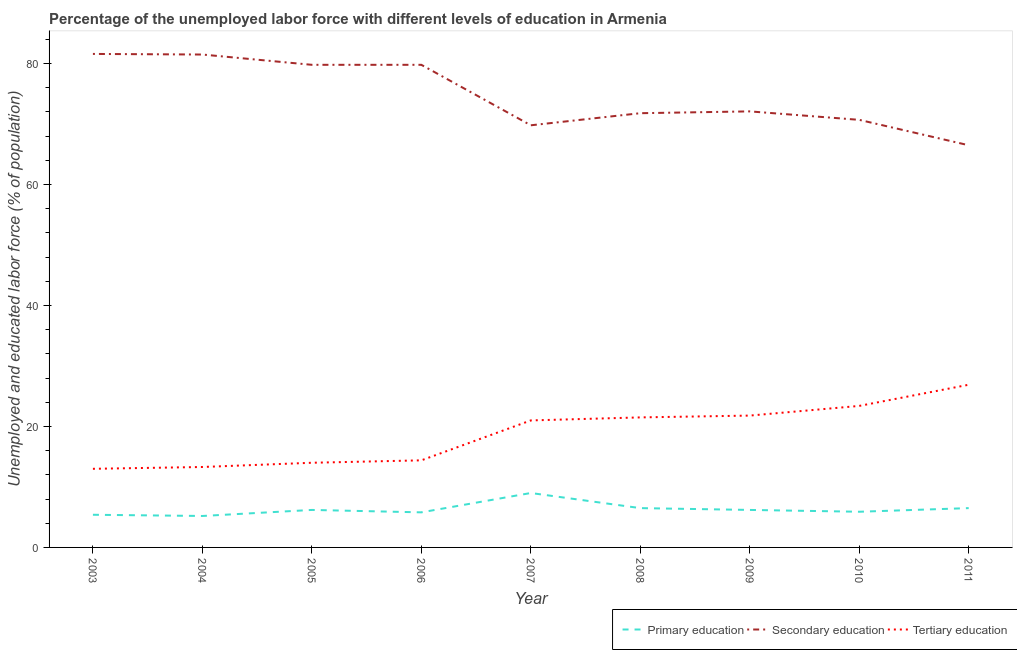How many different coloured lines are there?
Ensure brevity in your answer.  3. What is the percentage of labor force who received secondary education in 2009?
Your response must be concise. 72.1. Across all years, what is the maximum percentage of labor force who received secondary education?
Your answer should be compact. 81.6. In which year was the percentage of labor force who received primary education minimum?
Give a very brief answer. 2004. What is the total percentage of labor force who received tertiary education in the graph?
Offer a terse response. 169.3. What is the difference between the percentage of labor force who received secondary education in 2007 and that in 2008?
Make the answer very short. -2. What is the difference between the percentage of labor force who received tertiary education in 2008 and the percentage of labor force who received primary education in 2009?
Offer a terse response. 15.3. What is the average percentage of labor force who received tertiary education per year?
Your answer should be very brief. 18.81. In the year 2008, what is the difference between the percentage of labor force who received tertiary education and percentage of labor force who received primary education?
Keep it short and to the point. 15. What is the ratio of the percentage of labor force who received primary education in 2008 to that in 2010?
Provide a short and direct response. 1.1. Is the difference between the percentage of labor force who received secondary education in 2010 and 2011 greater than the difference between the percentage of labor force who received tertiary education in 2010 and 2011?
Offer a very short reply. Yes. What is the difference between the highest and the second highest percentage of labor force who received secondary education?
Give a very brief answer. 0.1. What is the difference between the highest and the lowest percentage of labor force who received tertiary education?
Give a very brief answer. 13.9. In how many years, is the percentage of labor force who received secondary education greater than the average percentage of labor force who received secondary education taken over all years?
Make the answer very short. 4. Is it the case that in every year, the sum of the percentage of labor force who received primary education and percentage of labor force who received secondary education is greater than the percentage of labor force who received tertiary education?
Your answer should be very brief. Yes. What is the difference between two consecutive major ticks on the Y-axis?
Give a very brief answer. 20. Does the graph contain grids?
Your answer should be very brief. No. How many legend labels are there?
Offer a very short reply. 3. What is the title of the graph?
Provide a succinct answer. Percentage of the unemployed labor force with different levels of education in Armenia. Does "Spain" appear as one of the legend labels in the graph?
Keep it short and to the point. No. What is the label or title of the X-axis?
Your answer should be compact. Year. What is the label or title of the Y-axis?
Offer a very short reply. Unemployed and educated labor force (% of population). What is the Unemployed and educated labor force (% of population) of Primary education in 2003?
Your answer should be compact. 5.4. What is the Unemployed and educated labor force (% of population) in Secondary education in 2003?
Make the answer very short. 81.6. What is the Unemployed and educated labor force (% of population) in Tertiary education in 2003?
Your response must be concise. 13. What is the Unemployed and educated labor force (% of population) in Primary education in 2004?
Give a very brief answer. 5.2. What is the Unemployed and educated labor force (% of population) of Secondary education in 2004?
Provide a succinct answer. 81.5. What is the Unemployed and educated labor force (% of population) of Tertiary education in 2004?
Provide a succinct answer. 13.3. What is the Unemployed and educated labor force (% of population) of Primary education in 2005?
Your answer should be compact. 6.2. What is the Unemployed and educated labor force (% of population) of Secondary education in 2005?
Offer a terse response. 79.8. What is the Unemployed and educated labor force (% of population) in Tertiary education in 2005?
Keep it short and to the point. 14. What is the Unemployed and educated labor force (% of population) in Primary education in 2006?
Make the answer very short. 5.8. What is the Unemployed and educated labor force (% of population) of Secondary education in 2006?
Your answer should be very brief. 79.8. What is the Unemployed and educated labor force (% of population) of Tertiary education in 2006?
Keep it short and to the point. 14.4. What is the Unemployed and educated labor force (% of population) in Primary education in 2007?
Your answer should be compact. 9. What is the Unemployed and educated labor force (% of population) of Secondary education in 2007?
Offer a very short reply. 69.8. What is the Unemployed and educated labor force (% of population) in Tertiary education in 2007?
Offer a very short reply. 21. What is the Unemployed and educated labor force (% of population) of Secondary education in 2008?
Offer a very short reply. 71.8. What is the Unemployed and educated labor force (% of population) of Primary education in 2009?
Your response must be concise. 6.2. What is the Unemployed and educated labor force (% of population) in Secondary education in 2009?
Give a very brief answer. 72.1. What is the Unemployed and educated labor force (% of population) of Tertiary education in 2009?
Make the answer very short. 21.8. What is the Unemployed and educated labor force (% of population) in Primary education in 2010?
Keep it short and to the point. 5.9. What is the Unemployed and educated labor force (% of population) of Secondary education in 2010?
Give a very brief answer. 70.7. What is the Unemployed and educated labor force (% of population) of Tertiary education in 2010?
Offer a very short reply. 23.4. What is the Unemployed and educated labor force (% of population) of Secondary education in 2011?
Your response must be concise. 66.5. What is the Unemployed and educated labor force (% of population) in Tertiary education in 2011?
Give a very brief answer. 26.9. Across all years, what is the maximum Unemployed and educated labor force (% of population) of Secondary education?
Give a very brief answer. 81.6. Across all years, what is the maximum Unemployed and educated labor force (% of population) of Tertiary education?
Your answer should be very brief. 26.9. Across all years, what is the minimum Unemployed and educated labor force (% of population) of Primary education?
Keep it short and to the point. 5.2. Across all years, what is the minimum Unemployed and educated labor force (% of population) in Secondary education?
Provide a succinct answer. 66.5. Across all years, what is the minimum Unemployed and educated labor force (% of population) in Tertiary education?
Make the answer very short. 13. What is the total Unemployed and educated labor force (% of population) of Primary education in the graph?
Offer a very short reply. 56.7. What is the total Unemployed and educated labor force (% of population) of Secondary education in the graph?
Keep it short and to the point. 673.6. What is the total Unemployed and educated labor force (% of population) of Tertiary education in the graph?
Provide a succinct answer. 169.3. What is the difference between the Unemployed and educated labor force (% of population) in Primary education in 2003 and that in 2004?
Your answer should be compact. 0.2. What is the difference between the Unemployed and educated labor force (% of population) in Secondary education in 2003 and that in 2004?
Keep it short and to the point. 0.1. What is the difference between the Unemployed and educated labor force (% of population) of Secondary education in 2003 and that in 2005?
Offer a terse response. 1.8. What is the difference between the Unemployed and educated labor force (% of population) of Tertiary education in 2003 and that in 2005?
Provide a succinct answer. -1. What is the difference between the Unemployed and educated labor force (% of population) of Secondary education in 2003 and that in 2006?
Your response must be concise. 1.8. What is the difference between the Unemployed and educated labor force (% of population) in Tertiary education in 2003 and that in 2006?
Your response must be concise. -1.4. What is the difference between the Unemployed and educated labor force (% of population) in Tertiary education in 2003 and that in 2007?
Give a very brief answer. -8. What is the difference between the Unemployed and educated labor force (% of population) in Primary education in 2003 and that in 2010?
Give a very brief answer. -0.5. What is the difference between the Unemployed and educated labor force (% of population) in Primary education in 2004 and that in 2005?
Your answer should be very brief. -1. What is the difference between the Unemployed and educated labor force (% of population) of Secondary education in 2004 and that in 2006?
Keep it short and to the point. 1.7. What is the difference between the Unemployed and educated labor force (% of population) of Primary education in 2004 and that in 2007?
Your answer should be compact. -3.8. What is the difference between the Unemployed and educated labor force (% of population) in Secondary education in 2004 and that in 2007?
Your answer should be very brief. 11.7. What is the difference between the Unemployed and educated labor force (% of population) of Tertiary education in 2004 and that in 2007?
Your response must be concise. -7.7. What is the difference between the Unemployed and educated labor force (% of population) of Secondary education in 2004 and that in 2008?
Offer a terse response. 9.7. What is the difference between the Unemployed and educated labor force (% of population) in Tertiary education in 2004 and that in 2008?
Make the answer very short. -8.2. What is the difference between the Unemployed and educated labor force (% of population) in Primary education in 2004 and that in 2009?
Ensure brevity in your answer.  -1. What is the difference between the Unemployed and educated labor force (% of population) in Secondary education in 2004 and that in 2009?
Keep it short and to the point. 9.4. What is the difference between the Unemployed and educated labor force (% of population) in Tertiary education in 2004 and that in 2011?
Your answer should be compact. -13.6. What is the difference between the Unemployed and educated labor force (% of population) of Primary education in 2005 and that in 2006?
Keep it short and to the point. 0.4. What is the difference between the Unemployed and educated labor force (% of population) of Secondary education in 2005 and that in 2007?
Ensure brevity in your answer.  10. What is the difference between the Unemployed and educated labor force (% of population) in Primary education in 2005 and that in 2008?
Your answer should be very brief. -0.3. What is the difference between the Unemployed and educated labor force (% of population) in Tertiary education in 2005 and that in 2008?
Give a very brief answer. -7.5. What is the difference between the Unemployed and educated labor force (% of population) in Primary education in 2005 and that in 2009?
Ensure brevity in your answer.  0. What is the difference between the Unemployed and educated labor force (% of population) in Secondary education in 2005 and that in 2009?
Provide a succinct answer. 7.7. What is the difference between the Unemployed and educated labor force (% of population) of Primary education in 2005 and that in 2010?
Provide a short and direct response. 0.3. What is the difference between the Unemployed and educated labor force (% of population) of Tertiary education in 2005 and that in 2010?
Make the answer very short. -9.4. What is the difference between the Unemployed and educated labor force (% of population) in Primary education in 2005 and that in 2011?
Your answer should be compact. -0.3. What is the difference between the Unemployed and educated labor force (% of population) of Secondary education in 2005 and that in 2011?
Your answer should be very brief. 13.3. What is the difference between the Unemployed and educated labor force (% of population) in Tertiary education in 2005 and that in 2011?
Provide a succinct answer. -12.9. What is the difference between the Unemployed and educated labor force (% of population) in Primary education in 2006 and that in 2007?
Provide a succinct answer. -3.2. What is the difference between the Unemployed and educated labor force (% of population) of Secondary education in 2006 and that in 2007?
Your answer should be compact. 10. What is the difference between the Unemployed and educated labor force (% of population) in Tertiary education in 2006 and that in 2007?
Provide a succinct answer. -6.6. What is the difference between the Unemployed and educated labor force (% of population) of Secondary education in 2006 and that in 2008?
Your answer should be compact. 8. What is the difference between the Unemployed and educated labor force (% of population) of Primary education in 2006 and that in 2009?
Offer a terse response. -0.4. What is the difference between the Unemployed and educated labor force (% of population) in Secondary education in 2006 and that in 2009?
Ensure brevity in your answer.  7.7. What is the difference between the Unemployed and educated labor force (% of population) in Primary education in 2006 and that in 2010?
Offer a very short reply. -0.1. What is the difference between the Unemployed and educated labor force (% of population) in Secondary education in 2006 and that in 2010?
Ensure brevity in your answer.  9.1. What is the difference between the Unemployed and educated labor force (% of population) of Tertiary education in 2006 and that in 2010?
Make the answer very short. -9. What is the difference between the Unemployed and educated labor force (% of population) in Primary education in 2006 and that in 2011?
Provide a succinct answer. -0.7. What is the difference between the Unemployed and educated labor force (% of population) of Secondary education in 2006 and that in 2011?
Provide a short and direct response. 13.3. What is the difference between the Unemployed and educated labor force (% of population) of Tertiary education in 2006 and that in 2011?
Give a very brief answer. -12.5. What is the difference between the Unemployed and educated labor force (% of population) in Primary education in 2007 and that in 2008?
Your answer should be very brief. 2.5. What is the difference between the Unemployed and educated labor force (% of population) of Secondary education in 2007 and that in 2008?
Your answer should be very brief. -2. What is the difference between the Unemployed and educated labor force (% of population) in Tertiary education in 2007 and that in 2009?
Offer a very short reply. -0.8. What is the difference between the Unemployed and educated labor force (% of population) in Secondary education in 2007 and that in 2010?
Give a very brief answer. -0.9. What is the difference between the Unemployed and educated labor force (% of population) of Primary education in 2007 and that in 2011?
Offer a terse response. 2.5. What is the difference between the Unemployed and educated labor force (% of population) of Tertiary education in 2007 and that in 2011?
Your answer should be very brief. -5.9. What is the difference between the Unemployed and educated labor force (% of population) in Primary education in 2008 and that in 2009?
Provide a short and direct response. 0.3. What is the difference between the Unemployed and educated labor force (% of population) in Primary education in 2008 and that in 2010?
Provide a succinct answer. 0.6. What is the difference between the Unemployed and educated labor force (% of population) of Tertiary education in 2008 and that in 2011?
Offer a very short reply. -5.4. What is the difference between the Unemployed and educated labor force (% of population) in Secondary education in 2009 and that in 2010?
Your response must be concise. 1.4. What is the difference between the Unemployed and educated labor force (% of population) in Tertiary education in 2009 and that in 2010?
Provide a short and direct response. -1.6. What is the difference between the Unemployed and educated labor force (% of population) in Secondary education in 2009 and that in 2011?
Offer a terse response. 5.6. What is the difference between the Unemployed and educated labor force (% of population) in Tertiary education in 2009 and that in 2011?
Give a very brief answer. -5.1. What is the difference between the Unemployed and educated labor force (% of population) in Primary education in 2003 and the Unemployed and educated labor force (% of population) in Secondary education in 2004?
Give a very brief answer. -76.1. What is the difference between the Unemployed and educated labor force (% of population) of Primary education in 2003 and the Unemployed and educated labor force (% of population) of Tertiary education in 2004?
Keep it short and to the point. -7.9. What is the difference between the Unemployed and educated labor force (% of population) in Secondary education in 2003 and the Unemployed and educated labor force (% of population) in Tertiary education in 2004?
Provide a short and direct response. 68.3. What is the difference between the Unemployed and educated labor force (% of population) in Primary education in 2003 and the Unemployed and educated labor force (% of population) in Secondary education in 2005?
Provide a succinct answer. -74.4. What is the difference between the Unemployed and educated labor force (% of population) in Primary education in 2003 and the Unemployed and educated labor force (% of population) in Tertiary education in 2005?
Offer a very short reply. -8.6. What is the difference between the Unemployed and educated labor force (% of population) of Secondary education in 2003 and the Unemployed and educated labor force (% of population) of Tertiary education in 2005?
Give a very brief answer. 67.6. What is the difference between the Unemployed and educated labor force (% of population) in Primary education in 2003 and the Unemployed and educated labor force (% of population) in Secondary education in 2006?
Your answer should be very brief. -74.4. What is the difference between the Unemployed and educated labor force (% of population) in Primary education in 2003 and the Unemployed and educated labor force (% of population) in Tertiary education in 2006?
Your answer should be compact. -9. What is the difference between the Unemployed and educated labor force (% of population) of Secondary education in 2003 and the Unemployed and educated labor force (% of population) of Tertiary education in 2006?
Offer a terse response. 67.2. What is the difference between the Unemployed and educated labor force (% of population) of Primary education in 2003 and the Unemployed and educated labor force (% of population) of Secondary education in 2007?
Provide a succinct answer. -64.4. What is the difference between the Unemployed and educated labor force (% of population) in Primary education in 2003 and the Unemployed and educated labor force (% of population) in Tertiary education in 2007?
Keep it short and to the point. -15.6. What is the difference between the Unemployed and educated labor force (% of population) in Secondary education in 2003 and the Unemployed and educated labor force (% of population) in Tertiary education in 2007?
Your response must be concise. 60.6. What is the difference between the Unemployed and educated labor force (% of population) in Primary education in 2003 and the Unemployed and educated labor force (% of population) in Secondary education in 2008?
Make the answer very short. -66.4. What is the difference between the Unemployed and educated labor force (% of population) of Primary education in 2003 and the Unemployed and educated labor force (% of population) of Tertiary education in 2008?
Provide a succinct answer. -16.1. What is the difference between the Unemployed and educated labor force (% of population) of Secondary education in 2003 and the Unemployed and educated labor force (% of population) of Tertiary education in 2008?
Provide a short and direct response. 60.1. What is the difference between the Unemployed and educated labor force (% of population) of Primary education in 2003 and the Unemployed and educated labor force (% of population) of Secondary education in 2009?
Give a very brief answer. -66.7. What is the difference between the Unemployed and educated labor force (% of population) of Primary education in 2003 and the Unemployed and educated labor force (% of population) of Tertiary education in 2009?
Offer a very short reply. -16.4. What is the difference between the Unemployed and educated labor force (% of population) in Secondary education in 2003 and the Unemployed and educated labor force (% of population) in Tertiary education in 2009?
Your response must be concise. 59.8. What is the difference between the Unemployed and educated labor force (% of population) of Primary education in 2003 and the Unemployed and educated labor force (% of population) of Secondary education in 2010?
Your answer should be very brief. -65.3. What is the difference between the Unemployed and educated labor force (% of population) of Primary education in 2003 and the Unemployed and educated labor force (% of population) of Tertiary education in 2010?
Make the answer very short. -18. What is the difference between the Unemployed and educated labor force (% of population) in Secondary education in 2003 and the Unemployed and educated labor force (% of population) in Tertiary education in 2010?
Provide a short and direct response. 58.2. What is the difference between the Unemployed and educated labor force (% of population) of Primary education in 2003 and the Unemployed and educated labor force (% of population) of Secondary education in 2011?
Keep it short and to the point. -61.1. What is the difference between the Unemployed and educated labor force (% of population) of Primary education in 2003 and the Unemployed and educated labor force (% of population) of Tertiary education in 2011?
Offer a terse response. -21.5. What is the difference between the Unemployed and educated labor force (% of population) in Secondary education in 2003 and the Unemployed and educated labor force (% of population) in Tertiary education in 2011?
Offer a very short reply. 54.7. What is the difference between the Unemployed and educated labor force (% of population) of Primary education in 2004 and the Unemployed and educated labor force (% of population) of Secondary education in 2005?
Your response must be concise. -74.6. What is the difference between the Unemployed and educated labor force (% of population) of Secondary education in 2004 and the Unemployed and educated labor force (% of population) of Tertiary education in 2005?
Keep it short and to the point. 67.5. What is the difference between the Unemployed and educated labor force (% of population) of Primary education in 2004 and the Unemployed and educated labor force (% of population) of Secondary education in 2006?
Give a very brief answer. -74.6. What is the difference between the Unemployed and educated labor force (% of population) in Primary education in 2004 and the Unemployed and educated labor force (% of population) in Tertiary education in 2006?
Your response must be concise. -9.2. What is the difference between the Unemployed and educated labor force (% of population) in Secondary education in 2004 and the Unemployed and educated labor force (% of population) in Tertiary education in 2006?
Your answer should be compact. 67.1. What is the difference between the Unemployed and educated labor force (% of population) in Primary education in 2004 and the Unemployed and educated labor force (% of population) in Secondary education in 2007?
Your answer should be very brief. -64.6. What is the difference between the Unemployed and educated labor force (% of population) in Primary education in 2004 and the Unemployed and educated labor force (% of population) in Tertiary education in 2007?
Provide a succinct answer. -15.8. What is the difference between the Unemployed and educated labor force (% of population) in Secondary education in 2004 and the Unemployed and educated labor force (% of population) in Tertiary education in 2007?
Provide a short and direct response. 60.5. What is the difference between the Unemployed and educated labor force (% of population) in Primary education in 2004 and the Unemployed and educated labor force (% of population) in Secondary education in 2008?
Your response must be concise. -66.6. What is the difference between the Unemployed and educated labor force (% of population) in Primary education in 2004 and the Unemployed and educated labor force (% of population) in Tertiary education in 2008?
Offer a very short reply. -16.3. What is the difference between the Unemployed and educated labor force (% of population) of Primary education in 2004 and the Unemployed and educated labor force (% of population) of Secondary education in 2009?
Keep it short and to the point. -66.9. What is the difference between the Unemployed and educated labor force (% of population) in Primary education in 2004 and the Unemployed and educated labor force (% of population) in Tertiary education in 2009?
Offer a terse response. -16.6. What is the difference between the Unemployed and educated labor force (% of population) of Secondary education in 2004 and the Unemployed and educated labor force (% of population) of Tertiary education in 2009?
Provide a succinct answer. 59.7. What is the difference between the Unemployed and educated labor force (% of population) of Primary education in 2004 and the Unemployed and educated labor force (% of population) of Secondary education in 2010?
Your answer should be very brief. -65.5. What is the difference between the Unemployed and educated labor force (% of population) in Primary education in 2004 and the Unemployed and educated labor force (% of population) in Tertiary education in 2010?
Keep it short and to the point. -18.2. What is the difference between the Unemployed and educated labor force (% of population) of Secondary education in 2004 and the Unemployed and educated labor force (% of population) of Tertiary education in 2010?
Your answer should be very brief. 58.1. What is the difference between the Unemployed and educated labor force (% of population) of Primary education in 2004 and the Unemployed and educated labor force (% of population) of Secondary education in 2011?
Provide a short and direct response. -61.3. What is the difference between the Unemployed and educated labor force (% of population) in Primary education in 2004 and the Unemployed and educated labor force (% of population) in Tertiary education in 2011?
Ensure brevity in your answer.  -21.7. What is the difference between the Unemployed and educated labor force (% of population) in Secondary education in 2004 and the Unemployed and educated labor force (% of population) in Tertiary education in 2011?
Offer a very short reply. 54.6. What is the difference between the Unemployed and educated labor force (% of population) in Primary education in 2005 and the Unemployed and educated labor force (% of population) in Secondary education in 2006?
Offer a terse response. -73.6. What is the difference between the Unemployed and educated labor force (% of population) of Primary education in 2005 and the Unemployed and educated labor force (% of population) of Tertiary education in 2006?
Ensure brevity in your answer.  -8.2. What is the difference between the Unemployed and educated labor force (% of population) in Secondary education in 2005 and the Unemployed and educated labor force (% of population) in Tertiary education in 2006?
Offer a very short reply. 65.4. What is the difference between the Unemployed and educated labor force (% of population) in Primary education in 2005 and the Unemployed and educated labor force (% of population) in Secondary education in 2007?
Give a very brief answer. -63.6. What is the difference between the Unemployed and educated labor force (% of population) of Primary education in 2005 and the Unemployed and educated labor force (% of population) of Tertiary education in 2007?
Give a very brief answer. -14.8. What is the difference between the Unemployed and educated labor force (% of population) of Secondary education in 2005 and the Unemployed and educated labor force (% of population) of Tertiary education in 2007?
Ensure brevity in your answer.  58.8. What is the difference between the Unemployed and educated labor force (% of population) in Primary education in 2005 and the Unemployed and educated labor force (% of population) in Secondary education in 2008?
Ensure brevity in your answer.  -65.6. What is the difference between the Unemployed and educated labor force (% of population) in Primary education in 2005 and the Unemployed and educated labor force (% of population) in Tertiary education in 2008?
Give a very brief answer. -15.3. What is the difference between the Unemployed and educated labor force (% of population) of Secondary education in 2005 and the Unemployed and educated labor force (% of population) of Tertiary education in 2008?
Offer a terse response. 58.3. What is the difference between the Unemployed and educated labor force (% of population) in Primary education in 2005 and the Unemployed and educated labor force (% of population) in Secondary education in 2009?
Offer a terse response. -65.9. What is the difference between the Unemployed and educated labor force (% of population) of Primary education in 2005 and the Unemployed and educated labor force (% of population) of Tertiary education in 2009?
Keep it short and to the point. -15.6. What is the difference between the Unemployed and educated labor force (% of population) of Primary education in 2005 and the Unemployed and educated labor force (% of population) of Secondary education in 2010?
Keep it short and to the point. -64.5. What is the difference between the Unemployed and educated labor force (% of population) in Primary education in 2005 and the Unemployed and educated labor force (% of population) in Tertiary education in 2010?
Provide a succinct answer. -17.2. What is the difference between the Unemployed and educated labor force (% of population) of Secondary education in 2005 and the Unemployed and educated labor force (% of population) of Tertiary education in 2010?
Ensure brevity in your answer.  56.4. What is the difference between the Unemployed and educated labor force (% of population) of Primary education in 2005 and the Unemployed and educated labor force (% of population) of Secondary education in 2011?
Keep it short and to the point. -60.3. What is the difference between the Unemployed and educated labor force (% of population) in Primary education in 2005 and the Unemployed and educated labor force (% of population) in Tertiary education in 2011?
Offer a terse response. -20.7. What is the difference between the Unemployed and educated labor force (% of population) of Secondary education in 2005 and the Unemployed and educated labor force (% of population) of Tertiary education in 2011?
Offer a terse response. 52.9. What is the difference between the Unemployed and educated labor force (% of population) in Primary education in 2006 and the Unemployed and educated labor force (% of population) in Secondary education in 2007?
Your answer should be very brief. -64. What is the difference between the Unemployed and educated labor force (% of population) of Primary education in 2006 and the Unemployed and educated labor force (% of population) of Tertiary education in 2007?
Provide a short and direct response. -15.2. What is the difference between the Unemployed and educated labor force (% of population) of Secondary education in 2006 and the Unemployed and educated labor force (% of population) of Tertiary education in 2007?
Give a very brief answer. 58.8. What is the difference between the Unemployed and educated labor force (% of population) in Primary education in 2006 and the Unemployed and educated labor force (% of population) in Secondary education in 2008?
Offer a very short reply. -66. What is the difference between the Unemployed and educated labor force (% of population) of Primary education in 2006 and the Unemployed and educated labor force (% of population) of Tertiary education in 2008?
Your answer should be very brief. -15.7. What is the difference between the Unemployed and educated labor force (% of population) in Secondary education in 2006 and the Unemployed and educated labor force (% of population) in Tertiary education in 2008?
Your answer should be very brief. 58.3. What is the difference between the Unemployed and educated labor force (% of population) in Primary education in 2006 and the Unemployed and educated labor force (% of population) in Secondary education in 2009?
Ensure brevity in your answer.  -66.3. What is the difference between the Unemployed and educated labor force (% of population) of Primary education in 2006 and the Unemployed and educated labor force (% of population) of Tertiary education in 2009?
Give a very brief answer. -16. What is the difference between the Unemployed and educated labor force (% of population) in Primary education in 2006 and the Unemployed and educated labor force (% of population) in Secondary education in 2010?
Offer a terse response. -64.9. What is the difference between the Unemployed and educated labor force (% of population) in Primary education in 2006 and the Unemployed and educated labor force (% of population) in Tertiary education in 2010?
Provide a succinct answer. -17.6. What is the difference between the Unemployed and educated labor force (% of population) in Secondary education in 2006 and the Unemployed and educated labor force (% of population) in Tertiary education in 2010?
Your answer should be compact. 56.4. What is the difference between the Unemployed and educated labor force (% of population) of Primary education in 2006 and the Unemployed and educated labor force (% of population) of Secondary education in 2011?
Give a very brief answer. -60.7. What is the difference between the Unemployed and educated labor force (% of population) of Primary education in 2006 and the Unemployed and educated labor force (% of population) of Tertiary education in 2011?
Offer a terse response. -21.1. What is the difference between the Unemployed and educated labor force (% of population) in Secondary education in 2006 and the Unemployed and educated labor force (% of population) in Tertiary education in 2011?
Your response must be concise. 52.9. What is the difference between the Unemployed and educated labor force (% of population) of Primary education in 2007 and the Unemployed and educated labor force (% of population) of Secondary education in 2008?
Your answer should be very brief. -62.8. What is the difference between the Unemployed and educated labor force (% of population) in Primary education in 2007 and the Unemployed and educated labor force (% of population) in Tertiary education in 2008?
Provide a short and direct response. -12.5. What is the difference between the Unemployed and educated labor force (% of population) in Secondary education in 2007 and the Unemployed and educated labor force (% of population) in Tertiary education in 2008?
Ensure brevity in your answer.  48.3. What is the difference between the Unemployed and educated labor force (% of population) of Primary education in 2007 and the Unemployed and educated labor force (% of population) of Secondary education in 2009?
Provide a succinct answer. -63.1. What is the difference between the Unemployed and educated labor force (% of population) of Primary education in 2007 and the Unemployed and educated labor force (% of population) of Tertiary education in 2009?
Ensure brevity in your answer.  -12.8. What is the difference between the Unemployed and educated labor force (% of population) of Primary education in 2007 and the Unemployed and educated labor force (% of population) of Secondary education in 2010?
Keep it short and to the point. -61.7. What is the difference between the Unemployed and educated labor force (% of population) of Primary education in 2007 and the Unemployed and educated labor force (% of population) of Tertiary education in 2010?
Make the answer very short. -14.4. What is the difference between the Unemployed and educated labor force (% of population) in Secondary education in 2007 and the Unemployed and educated labor force (% of population) in Tertiary education in 2010?
Your response must be concise. 46.4. What is the difference between the Unemployed and educated labor force (% of population) in Primary education in 2007 and the Unemployed and educated labor force (% of population) in Secondary education in 2011?
Keep it short and to the point. -57.5. What is the difference between the Unemployed and educated labor force (% of population) of Primary education in 2007 and the Unemployed and educated labor force (% of population) of Tertiary education in 2011?
Make the answer very short. -17.9. What is the difference between the Unemployed and educated labor force (% of population) of Secondary education in 2007 and the Unemployed and educated labor force (% of population) of Tertiary education in 2011?
Provide a short and direct response. 42.9. What is the difference between the Unemployed and educated labor force (% of population) of Primary education in 2008 and the Unemployed and educated labor force (% of population) of Secondary education in 2009?
Ensure brevity in your answer.  -65.6. What is the difference between the Unemployed and educated labor force (% of population) of Primary education in 2008 and the Unemployed and educated labor force (% of population) of Tertiary education in 2009?
Your response must be concise. -15.3. What is the difference between the Unemployed and educated labor force (% of population) in Primary education in 2008 and the Unemployed and educated labor force (% of population) in Secondary education in 2010?
Offer a very short reply. -64.2. What is the difference between the Unemployed and educated labor force (% of population) of Primary education in 2008 and the Unemployed and educated labor force (% of population) of Tertiary education in 2010?
Provide a succinct answer. -16.9. What is the difference between the Unemployed and educated labor force (% of population) in Secondary education in 2008 and the Unemployed and educated labor force (% of population) in Tertiary education in 2010?
Offer a terse response. 48.4. What is the difference between the Unemployed and educated labor force (% of population) in Primary education in 2008 and the Unemployed and educated labor force (% of population) in Secondary education in 2011?
Ensure brevity in your answer.  -60. What is the difference between the Unemployed and educated labor force (% of population) in Primary education in 2008 and the Unemployed and educated labor force (% of population) in Tertiary education in 2011?
Offer a terse response. -20.4. What is the difference between the Unemployed and educated labor force (% of population) of Secondary education in 2008 and the Unemployed and educated labor force (% of population) of Tertiary education in 2011?
Provide a short and direct response. 44.9. What is the difference between the Unemployed and educated labor force (% of population) of Primary education in 2009 and the Unemployed and educated labor force (% of population) of Secondary education in 2010?
Your answer should be compact. -64.5. What is the difference between the Unemployed and educated labor force (% of population) of Primary education in 2009 and the Unemployed and educated labor force (% of population) of Tertiary education in 2010?
Offer a terse response. -17.2. What is the difference between the Unemployed and educated labor force (% of population) of Secondary education in 2009 and the Unemployed and educated labor force (% of population) of Tertiary education in 2010?
Offer a terse response. 48.7. What is the difference between the Unemployed and educated labor force (% of population) of Primary education in 2009 and the Unemployed and educated labor force (% of population) of Secondary education in 2011?
Provide a succinct answer. -60.3. What is the difference between the Unemployed and educated labor force (% of population) of Primary education in 2009 and the Unemployed and educated labor force (% of population) of Tertiary education in 2011?
Offer a very short reply. -20.7. What is the difference between the Unemployed and educated labor force (% of population) of Secondary education in 2009 and the Unemployed and educated labor force (% of population) of Tertiary education in 2011?
Your answer should be very brief. 45.2. What is the difference between the Unemployed and educated labor force (% of population) in Primary education in 2010 and the Unemployed and educated labor force (% of population) in Secondary education in 2011?
Provide a succinct answer. -60.6. What is the difference between the Unemployed and educated labor force (% of population) in Secondary education in 2010 and the Unemployed and educated labor force (% of population) in Tertiary education in 2011?
Keep it short and to the point. 43.8. What is the average Unemployed and educated labor force (% of population) of Primary education per year?
Your answer should be compact. 6.3. What is the average Unemployed and educated labor force (% of population) of Secondary education per year?
Your response must be concise. 74.84. What is the average Unemployed and educated labor force (% of population) in Tertiary education per year?
Give a very brief answer. 18.81. In the year 2003, what is the difference between the Unemployed and educated labor force (% of population) in Primary education and Unemployed and educated labor force (% of population) in Secondary education?
Offer a very short reply. -76.2. In the year 2003, what is the difference between the Unemployed and educated labor force (% of population) in Primary education and Unemployed and educated labor force (% of population) in Tertiary education?
Your answer should be compact. -7.6. In the year 2003, what is the difference between the Unemployed and educated labor force (% of population) of Secondary education and Unemployed and educated labor force (% of population) of Tertiary education?
Your answer should be compact. 68.6. In the year 2004, what is the difference between the Unemployed and educated labor force (% of population) of Primary education and Unemployed and educated labor force (% of population) of Secondary education?
Give a very brief answer. -76.3. In the year 2004, what is the difference between the Unemployed and educated labor force (% of population) of Secondary education and Unemployed and educated labor force (% of population) of Tertiary education?
Your answer should be very brief. 68.2. In the year 2005, what is the difference between the Unemployed and educated labor force (% of population) in Primary education and Unemployed and educated labor force (% of population) in Secondary education?
Provide a short and direct response. -73.6. In the year 2005, what is the difference between the Unemployed and educated labor force (% of population) of Primary education and Unemployed and educated labor force (% of population) of Tertiary education?
Make the answer very short. -7.8. In the year 2005, what is the difference between the Unemployed and educated labor force (% of population) of Secondary education and Unemployed and educated labor force (% of population) of Tertiary education?
Your answer should be compact. 65.8. In the year 2006, what is the difference between the Unemployed and educated labor force (% of population) in Primary education and Unemployed and educated labor force (% of population) in Secondary education?
Offer a terse response. -74. In the year 2006, what is the difference between the Unemployed and educated labor force (% of population) of Secondary education and Unemployed and educated labor force (% of population) of Tertiary education?
Make the answer very short. 65.4. In the year 2007, what is the difference between the Unemployed and educated labor force (% of population) of Primary education and Unemployed and educated labor force (% of population) of Secondary education?
Provide a short and direct response. -60.8. In the year 2007, what is the difference between the Unemployed and educated labor force (% of population) in Primary education and Unemployed and educated labor force (% of population) in Tertiary education?
Make the answer very short. -12. In the year 2007, what is the difference between the Unemployed and educated labor force (% of population) of Secondary education and Unemployed and educated labor force (% of population) of Tertiary education?
Offer a terse response. 48.8. In the year 2008, what is the difference between the Unemployed and educated labor force (% of population) of Primary education and Unemployed and educated labor force (% of population) of Secondary education?
Provide a short and direct response. -65.3. In the year 2008, what is the difference between the Unemployed and educated labor force (% of population) of Primary education and Unemployed and educated labor force (% of population) of Tertiary education?
Keep it short and to the point. -15. In the year 2008, what is the difference between the Unemployed and educated labor force (% of population) of Secondary education and Unemployed and educated labor force (% of population) of Tertiary education?
Keep it short and to the point. 50.3. In the year 2009, what is the difference between the Unemployed and educated labor force (% of population) in Primary education and Unemployed and educated labor force (% of population) in Secondary education?
Offer a very short reply. -65.9. In the year 2009, what is the difference between the Unemployed and educated labor force (% of population) in Primary education and Unemployed and educated labor force (% of population) in Tertiary education?
Your response must be concise. -15.6. In the year 2009, what is the difference between the Unemployed and educated labor force (% of population) of Secondary education and Unemployed and educated labor force (% of population) of Tertiary education?
Offer a terse response. 50.3. In the year 2010, what is the difference between the Unemployed and educated labor force (% of population) of Primary education and Unemployed and educated labor force (% of population) of Secondary education?
Offer a terse response. -64.8. In the year 2010, what is the difference between the Unemployed and educated labor force (% of population) of Primary education and Unemployed and educated labor force (% of population) of Tertiary education?
Offer a very short reply. -17.5. In the year 2010, what is the difference between the Unemployed and educated labor force (% of population) of Secondary education and Unemployed and educated labor force (% of population) of Tertiary education?
Keep it short and to the point. 47.3. In the year 2011, what is the difference between the Unemployed and educated labor force (% of population) in Primary education and Unemployed and educated labor force (% of population) in Secondary education?
Offer a very short reply. -60. In the year 2011, what is the difference between the Unemployed and educated labor force (% of population) of Primary education and Unemployed and educated labor force (% of population) of Tertiary education?
Your answer should be very brief. -20.4. In the year 2011, what is the difference between the Unemployed and educated labor force (% of population) of Secondary education and Unemployed and educated labor force (% of population) of Tertiary education?
Give a very brief answer. 39.6. What is the ratio of the Unemployed and educated labor force (% of population) of Tertiary education in 2003 to that in 2004?
Offer a very short reply. 0.98. What is the ratio of the Unemployed and educated labor force (% of population) in Primary education in 2003 to that in 2005?
Your answer should be very brief. 0.87. What is the ratio of the Unemployed and educated labor force (% of population) in Secondary education in 2003 to that in 2005?
Make the answer very short. 1.02. What is the ratio of the Unemployed and educated labor force (% of population) in Tertiary education in 2003 to that in 2005?
Offer a terse response. 0.93. What is the ratio of the Unemployed and educated labor force (% of population) in Primary education in 2003 to that in 2006?
Keep it short and to the point. 0.93. What is the ratio of the Unemployed and educated labor force (% of population) in Secondary education in 2003 to that in 2006?
Your answer should be very brief. 1.02. What is the ratio of the Unemployed and educated labor force (% of population) of Tertiary education in 2003 to that in 2006?
Give a very brief answer. 0.9. What is the ratio of the Unemployed and educated labor force (% of population) of Primary education in 2003 to that in 2007?
Offer a very short reply. 0.6. What is the ratio of the Unemployed and educated labor force (% of population) in Secondary education in 2003 to that in 2007?
Your response must be concise. 1.17. What is the ratio of the Unemployed and educated labor force (% of population) of Tertiary education in 2003 to that in 2007?
Your answer should be very brief. 0.62. What is the ratio of the Unemployed and educated labor force (% of population) of Primary education in 2003 to that in 2008?
Provide a short and direct response. 0.83. What is the ratio of the Unemployed and educated labor force (% of population) in Secondary education in 2003 to that in 2008?
Make the answer very short. 1.14. What is the ratio of the Unemployed and educated labor force (% of population) in Tertiary education in 2003 to that in 2008?
Your answer should be very brief. 0.6. What is the ratio of the Unemployed and educated labor force (% of population) in Primary education in 2003 to that in 2009?
Make the answer very short. 0.87. What is the ratio of the Unemployed and educated labor force (% of population) of Secondary education in 2003 to that in 2009?
Offer a terse response. 1.13. What is the ratio of the Unemployed and educated labor force (% of population) of Tertiary education in 2003 to that in 2009?
Give a very brief answer. 0.6. What is the ratio of the Unemployed and educated labor force (% of population) in Primary education in 2003 to that in 2010?
Provide a succinct answer. 0.92. What is the ratio of the Unemployed and educated labor force (% of population) in Secondary education in 2003 to that in 2010?
Ensure brevity in your answer.  1.15. What is the ratio of the Unemployed and educated labor force (% of population) in Tertiary education in 2003 to that in 2010?
Keep it short and to the point. 0.56. What is the ratio of the Unemployed and educated labor force (% of population) in Primary education in 2003 to that in 2011?
Make the answer very short. 0.83. What is the ratio of the Unemployed and educated labor force (% of population) of Secondary education in 2003 to that in 2011?
Your answer should be compact. 1.23. What is the ratio of the Unemployed and educated labor force (% of population) of Tertiary education in 2003 to that in 2011?
Keep it short and to the point. 0.48. What is the ratio of the Unemployed and educated labor force (% of population) in Primary education in 2004 to that in 2005?
Offer a terse response. 0.84. What is the ratio of the Unemployed and educated labor force (% of population) of Secondary education in 2004 to that in 2005?
Offer a terse response. 1.02. What is the ratio of the Unemployed and educated labor force (% of population) in Tertiary education in 2004 to that in 2005?
Your answer should be compact. 0.95. What is the ratio of the Unemployed and educated labor force (% of population) of Primary education in 2004 to that in 2006?
Offer a terse response. 0.9. What is the ratio of the Unemployed and educated labor force (% of population) of Secondary education in 2004 to that in 2006?
Ensure brevity in your answer.  1.02. What is the ratio of the Unemployed and educated labor force (% of population) in Tertiary education in 2004 to that in 2006?
Keep it short and to the point. 0.92. What is the ratio of the Unemployed and educated labor force (% of population) of Primary education in 2004 to that in 2007?
Your answer should be compact. 0.58. What is the ratio of the Unemployed and educated labor force (% of population) of Secondary education in 2004 to that in 2007?
Offer a very short reply. 1.17. What is the ratio of the Unemployed and educated labor force (% of population) of Tertiary education in 2004 to that in 2007?
Your answer should be very brief. 0.63. What is the ratio of the Unemployed and educated labor force (% of population) of Primary education in 2004 to that in 2008?
Give a very brief answer. 0.8. What is the ratio of the Unemployed and educated labor force (% of population) in Secondary education in 2004 to that in 2008?
Ensure brevity in your answer.  1.14. What is the ratio of the Unemployed and educated labor force (% of population) of Tertiary education in 2004 to that in 2008?
Ensure brevity in your answer.  0.62. What is the ratio of the Unemployed and educated labor force (% of population) in Primary education in 2004 to that in 2009?
Offer a terse response. 0.84. What is the ratio of the Unemployed and educated labor force (% of population) in Secondary education in 2004 to that in 2009?
Ensure brevity in your answer.  1.13. What is the ratio of the Unemployed and educated labor force (% of population) in Tertiary education in 2004 to that in 2009?
Offer a very short reply. 0.61. What is the ratio of the Unemployed and educated labor force (% of population) in Primary education in 2004 to that in 2010?
Ensure brevity in your answer.  0.88. What is the ratio of the Unemployed and educated labor force (% of population) in Secondary education in 2004 to that in 2010?
Your answer should be compact. 1.15. What is the ratio of the Unemployed and educated labor force (% of population) in Tertiary education in 2004 to that in 2010?
Give a very brief answer. 0.57. What is the ratio of the Unemployed and educated labor force (% of population) of Primary education in 2004 to that in 2011?
Offer a very short reply. 0.8. What is the ratio of the Unemployed and educated labor force (% of population) in Secondary education in 2004 to that in 2011?
Provide a short and direct response. 1.23. What is the ratio of the Unemployed and educated labor force (% of population) in Tertiary education in 2004 to that in 2011?
Ensure brevity in your answer.  0.49. What is the ratio of the Unemployed and educated labor force (% of population) of Primary education in 2005 to that in 2006?
Offer a very short reply. 1.07. What is the ratio of the Unemployed and educated labor force (% of population) in Secondary education in 2005 to that in 2006?
Your answer should be very brief. 1. What is the ratio of the Unemployed and educated labor force (% of population) in Tertiary education in 2005 to that in 2006?
Give a very brief answer. 0.97. What is the ratio of the Unemployed and educated labor force (% of population) in Primary education in 2005 to that in 2007?
Give a very brief answer. 0.69. What is the ratio of the Unemployed and educated labor force (% of population) in Secondary education in 2005 to that in 2007?
Make the answer very short. 1.14. What is the ratio of the Unemployed and educated labor force (% of population) in Tertiary education in 2005 to that in 2007?
Keep it short and to the point. 0.67. What is the ratio of the Unemployed and educated labor force (% of population) of Primary education in 2005 to that in 2008?
Give a very brief answer. 0.95. What is the ratio of the Unemployed and educated labor force (% of population) in Secondary education in 2005 to that in 2008?
Your response must be concise. 1.11. What is the ratio of the Unemployed and educated labor force (% of population) of Tertiary education in 2005 to that in 2008?
Ensure brevity in your answer.  0.65. What is the ratio of the Unemployed and educated labor force (% of population) in Secondary education in 2005 to that in 2009?
Give a very brief answer. 1.11. What is the ratio of the Unemployed and educated labor force (% of population) of Tertiary education in 2005 to that in 2009?
Keep it short and to the point. 0.64. What is the ratio of the Unemployed and educated labor force (% of population) in Primary education in 2005 to that in 2010?
Offer a terse response. 1.05. What is the ratio of the Unemployed and educated labor force (% of population) of Secondary education in 2005 to that in 2010?
Give a very brief answer. 1.13. What is the ratio of the Unemployed and educated labor force (% of population) of Tertiary education in 2005 to that in 2010?
Offer a terse response. 0.6. What is the ratio of the Unemployed and educated labor force (% of population) in Primary education in 2005 to that in 2011?
Provide a succinct answer. 0.95. What is the ratio of the Unemployed and educated labor force (% of population) of Tertiary education in 2005 to that in 2011?
Provide a short and direct response. 0.52. What is the ratio of the Unemployed and educated labor force (% of population) in Primary education in 2006 to that in 2007?
Offer a very short reply. 0.64. What is the ratio of the Unemployed and educated labor force (% of population) of Secondary education in 2006 to that in 2007?
Make the answer very short. 1.14. What is the ratio of the Unemployed and educated labor force (% of population) in Tertiary education in 2006 to that in 2007?
Your answer should be compact. 0.69. What is the ratio of the Unemployed and educated labor force (% of population) of Primary education in 2006 to that in 2008?
Keep it short and to the point. 0.89. What is the ratio of the Unemployed and educated labor force (% of population) of Secondary education in 2006 to that in 2008?
Ensure brevity in your answer.  1.11. What is the ratio of the Unemployed and educated labor force (% of population) of Tertiary education in 2006 to that in 2008?
Offer a very short reply. 0.67. What is the ratio of the Unemployed and educated labor force (% of population) of Primary education in 2006 to that in 2009?
Keep it short and to the point. 0.94. What is the ratio of the Unemployed and educated labor force (% of population) of Secondary education in 2006 to that in 2009?
Give a very brief answer. 1.11. What is the ratio of the Unemployed and educated labor force (% of population) in Tertiary education in 2006 to that in 2009?
Give a very brief answer. 0.66. What is the ratio of the Unemployed and educated labor force (% of population) of Primary education in 2006 to that in 2010?
Give a very brief answer. 0.98. What is the ratio of the Unemployed and educated labor force (% of population) of Secondary education in 2006 to that in 2010?
Offer a very short reply. 1.13. What is the ratio of the Unemployed and educated labor force (% of population) in Tertiary education in 2006 to that in 2010?
Ensure brevity in your answer.  0.62. What is the ratio of the Unemployed and educated labor force (% of population) in Primary education in 2006 to that in 2011?
Keep it short and to the point. 0.89. What is the ratio of the Unemployed and educated labor force (% of population) in Tertiary education in 2006 to that in 2011?
Provide a short and direct response. 0.54. What is the ratio of the Unemployed and educated labor force (% of population) of Primary education in 2007 to that in 2008?
Keep it short and to the point. 1.38. What is the ratio of the Unemployed and educated labor force (% of population) in Secondary education in 2007 to that in 2008?
Your answer should be compact. 0.97. What is the ratio of the Unemployed and educated labor force (% of population) in Tertiary education in 2007 to that in 2008?
Provide a short and direct response. 0.98. What is the ratio of the Unemployed and educated labor force (% of population) in Primary education in 2007 to that in 2009?
Offer a terse response. 1.45. What is the ratio of the Unemployed and educated labor force (% of population) of Secondary education in 2007 to that in 2009?
Ensure brevity in your answer.  0.97. What is the ratio of the Unemployed and educated labor force (% of population) in Tertiary education in 2007 to that in 2009?
Your answer should be compact. 0.96. What is the ratio of the Unemployed and educated labor force (% of population) of Primary education in 2007 to that in 2010?
Provide a succinct answer. 1.53. What is the ratio of the Unemployed and educated labor force (% of population) of Secondary education in 2007 to that in 2010?
Provide a short and direct response. 0.99. What is the ratio of the Unemployed and educated labor force (% of population) of Tertiary education in 2007 to that in 2010?
Give a very brief answer. 0.9. What is the ratio of the Unemployed and educated labor force (% of population) of Primary education in 2007 to that in 2011?
Provide a short and direct response. 1.38. What is the ratio of the Unemployed and educated labor force (% of population) of Secondary education in 2007 to that in 2011?
Give a very brief answer. 1.05. What is the ratio of the Unemployed and educated labor force (% of population) of Tertiary education in 2007 to that in 2011?
Your response must be concise. 0.78. What is the ratio of the Unemployed and educated labor force (% of population) in Primary education in 2008 to that in 2009?
Give a very brief answer. 1.05. What is the ratio of the Unemployed and educated labor force (% of population) of Tertiary education in 2008 to that in 2009?
Keep it short and to the point. 0.99. What is the ratio of the Unemployed and educated labor force (% of population) of Primary education in 2008 to that in 2010?
Your answer should be very brief. 1.1. What is the ratio of the Unemployed and educated labor force (% of population) in Secondary education in 2008 to that in 2010?
Your response must be concise. 1.02. What is the ratio of the Unemployed and educated labor force (% of population) of Tertiary education in 2008 to that in 2010?
Give a very brief answer. 0.92. What is the ratio of the Unemployed and educated labor force (% of population) in Secondary education in 2008 to that in 2011?
Give a very brief answer. 1.08. What is the ratio of the Unemployed and educated labor force (% of population) of Tertiary education in 2008 to that in 2011?
Your answer should be compact. 0.8. What is the ratio of the Unemployed and educated labor force (% of population) of Primary education in 2009 to that in 2010?
Your answer should be very brief. 1.05. What is the ratio of the Unemployed and educated labor force (% of population) in Secondary education in 2009 to that in 2010?
Your response must be concise. 1.02. What is the ratio of the Unemployed and educated labor force (% of population) of Tertiary education in 2009 to that in 2010?
Offer a very short reply. 0.93. What is the ratio of the Unemployed and educated labor force (% of population) in Primary education in 2009 to that in 2011?
Provide a succinct answer. 0.95. What is the ratio of the Unemployed and educated labor force (% of population) of Secondary education in 2009 to that in 2011?
Your answer should be very brief. 1.08. What is the ratio of the Unemployed and educated labor force (% of population) of Tertiary education in 2009 to that in 2011?
Give a very brief answer. 0.81. What is the ratio of the Unemployed and educated labor force (% of population) of Primary education in 2010 to that in 2011?
Your answer should be compact. 0.91. What is the ratio of the Unemployed and educated labor force (% of population) in Secondary education in 2010 to that in 2011?
Your answer should be very brief. 1.06. What is the ratio of the Unemployed and educated labor force (% of population) in Tertiary education in 2010 to that in 2011?
Your response must be concise. 0.87. What is the difference between the highest and the second highest Unemployed and educated labor force (% of population) in Primary education?
Make the answer very short. 2.5. What is the difference between the highest and the lowest Unemployed and educated labor force (% of population) in Primary education?
Offer a very short reply. 3.8. 